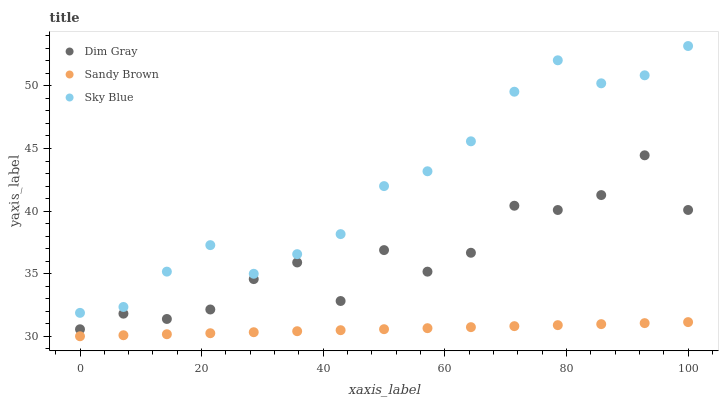Does Sandy Brown have the minimum area under the curve?
Answer yes or no. Yes. Does Sky Blue have the maximum area under the curve?
Answer yes or no. Yes. Does Dim Gray have the minimum area under the curve?
Answer yes or no. No. Does Dim Gray have the maximum area under the curve?
Answer yes or no. No. Is Sandy Brown the smoothest?
Answer yes or no. Yes. Is Dim Gray the roughest?
Answer yes or no. Yes. Is Dim Gray the smoothest?
Answer yes or no. No. Is Sandy Brown the roughest?
Answer yes or no. No. Does Sandy Brown have the lowest value?
Answer yes or no. Yes. Does Dim Gray have the lowest value?
Answer yes or no. No. Does Sky Blue have the highest value?
Answer yes or no. Yes. Does Dim Gray have the highest value?
Answer yes or no. No. Is Sandy Brown less than Dim Gray?
Answer yes or no. Yes. Is Dim Gray greater than Sandy Brown?
Answer yes or no. Yes. Does Sandy Brown intersect Dim Gray?
Answer yes or no. No. 